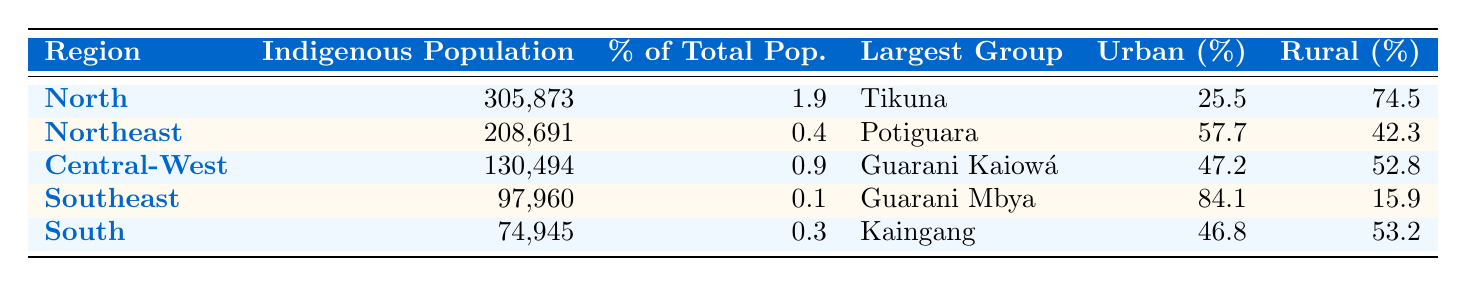What is the indigenous population in the Northeast region? The table shows that the indigenous population in the Northeast region is 208,691.
Answer: 208,691 Which region has the largest indigenous population? According to the table, the North region has the largest indigenous population, which is 305,873.
Answer: North What percentage of the Southeast's total population is indigenous? The table indicates that the percentage of the total population that is indigenous in the Southeast region is 0.1%.
Answer: 0.1% Which indigenous group has the highest percentage of urban population in the South region? The table presents that the Kaingang group in the South region has an urban population percentage of 46.8%.
Answer: Kaingang Is the percentage of rural indigenous population in the North region higher than in the Southeast region? The North region has a rural indigenous population of 74.5%, while the Southeast has 15.9%, indicating that the North's percentage is higher.
Answer: Yes What is the total indigenous population across all regions? By summing the populations: 305,873 (North) + 208,691 (Northeast) + 130,494 (Central-West) + 97,960 (Southeast) + 74,945 (South) gives a total of 818,963.
Answer: 818,963 In which region is the urban indigenous population percentage over 50%? The Northeast region has an urban indigenous population percentage of 57.7%, which is over 50%.
Answer: Northeast Which indigenous group has the smallest population based on the table? The smallest indigenous population is in the South region with the Kaingang group, totaling 74,945.
Answer: Kaingang What is the difference in percentage of rural indigenous population between the Northeast and Central-West regions? The Northeast has a rural population of 42.3% and Central-West has 52.8%, so the difference is 52.8% - 42.3% = 10.5%.
Answer: 10.5% Which region has the Tikuna as the largest indigenous group? The North region is listed in the table as having the Tikuna as the largest indigenous group.
Answer: North 